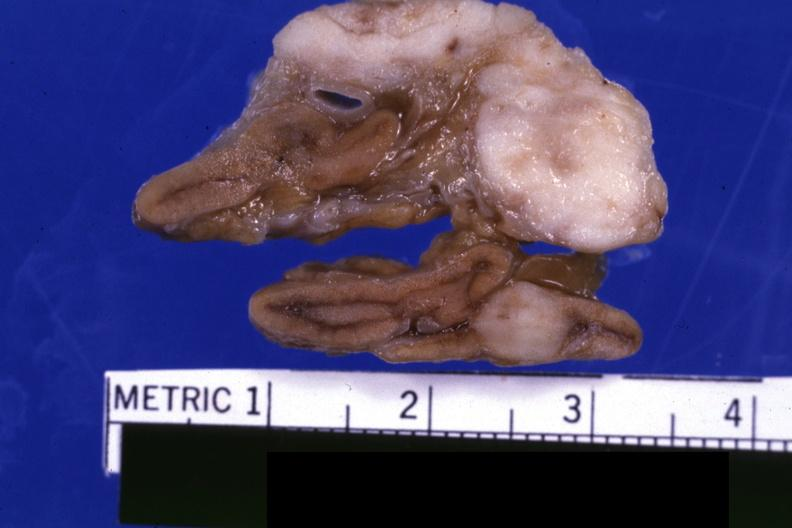what is present?
Answer the question using a single word or phrase. Metastatic carcinoma 